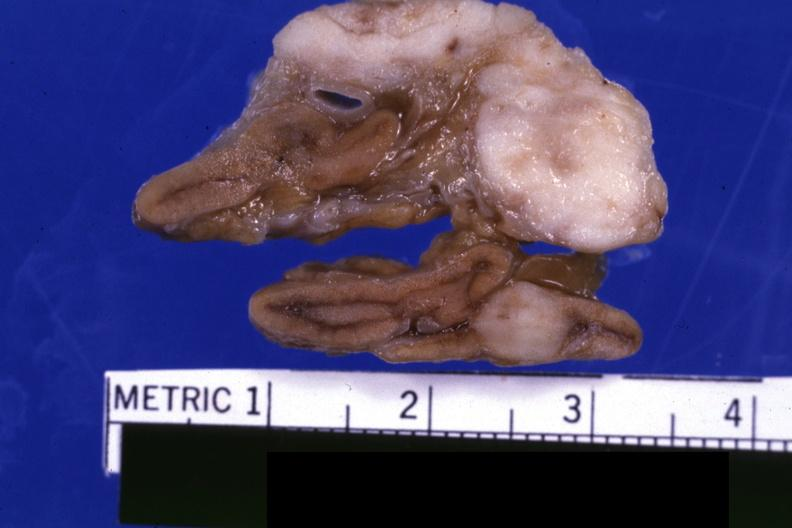what is present?
Answer the question using a single word or phrase. Metastatic carcinoma 